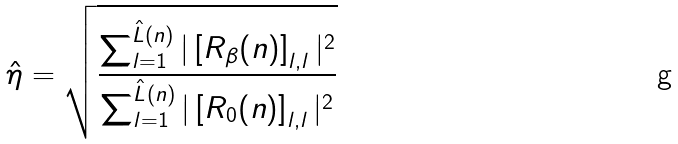Convert formula to latex. <formula><loc_0><loc_0><loc_500><loc_500>\hat { \eta } = \sqrt { \frac { \sum \nolimits _ { l = 1 } ^ { { \hat { L } } ( n ) } | \left [ { R } _ { \beta } ( n ) \right ] _ { l , l } | ^ { 2 } } { \sum \nolimits _ { l = 1 } ^ { { \hat { L } } ( n ) } | \left [ { R } _ { 0 } ( n ) \right ] _ { l , l } | ^ { 2 } } }</formula> 